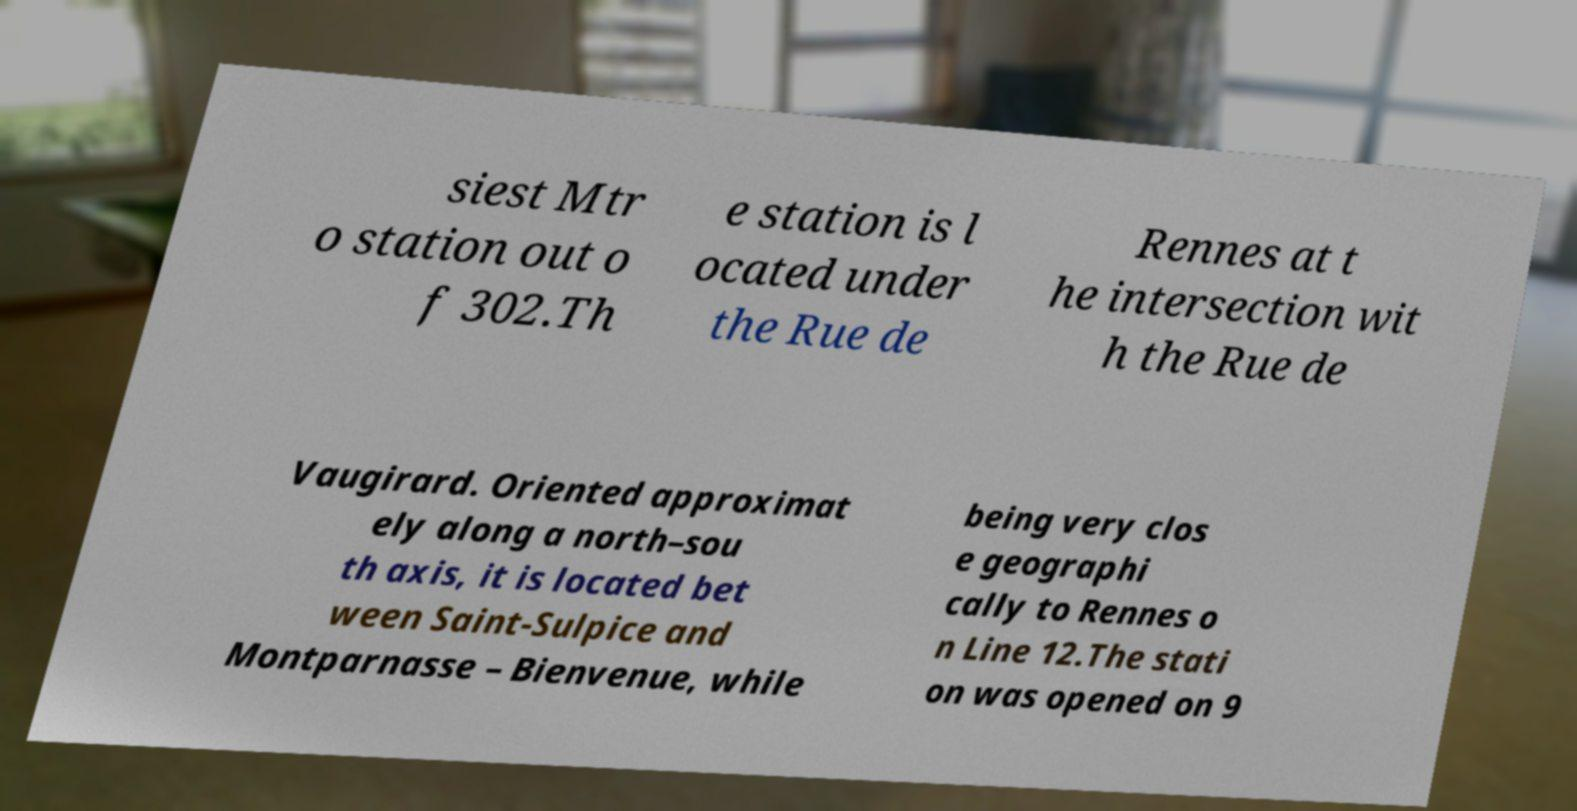Could you extract and type out the text from this image? siest Mtr o station out o f 302.Th e station is l ocated under the Rue de Rennes at t he intersection wit h the Rue de Vaugirard. Oriented approximat ely along a north–sou th axis, it is located bet ween Saint-Sulpice and Montparnasse – Bienvenue, while being very clos e geographi cally to Rennes o n Line 12.The stati on was opened on 9 